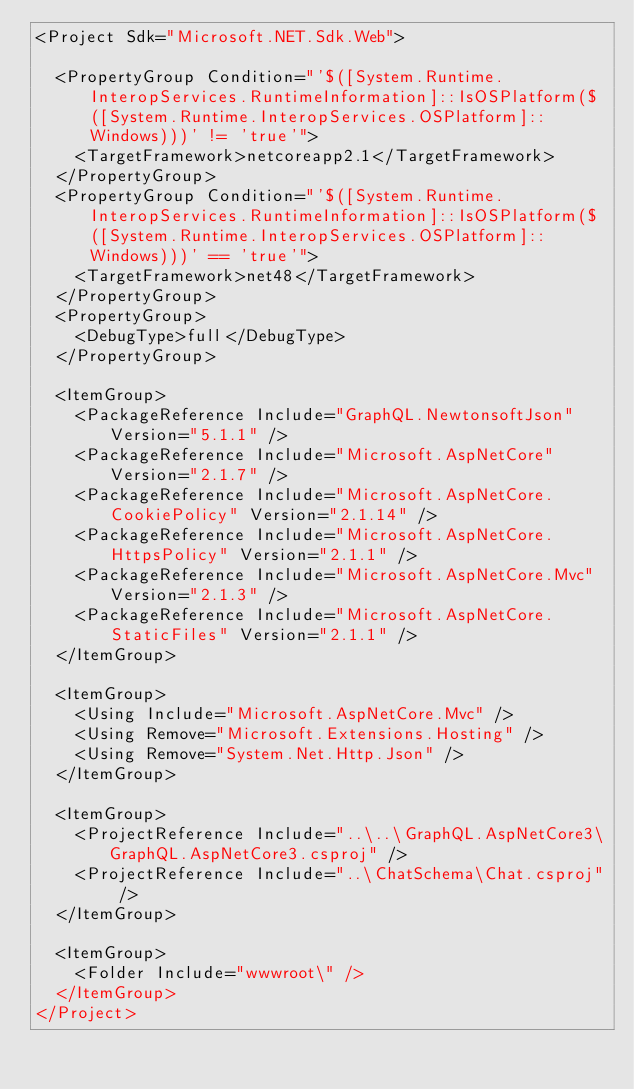<code> <loc_0><loc_0><loc_500><loc_500><_XML_><Project Sdk="Microsoft.NET.Sdk.Web">

  <PropertyGroup Condition="'$([System.Runtime.InteropServices.RuntimeInformation]::IsOSPlatform($([System.Runtime.InteropServices.OSPlatform]::Windows)))' != 'true'">
    <TargetFramework>netcoreapp2.1</TargetFramework>
  </PropertyGroup>
  <PropertyGroup Condition="'$([System.Runtime.InteropServices.RuntimeInformation]::IsOSPlatform($([System.Runtime.InteropServices.OSPlatform]::Windows)))' == 'true'">
    <TargetFramework>net48</TargetFramework>
  </PropertyGroup>
  <PropertyGroup>
    <DebugType>full</DebugType>
  </PropertyGroup>

  <ItemGroup>
    <PackageReference Include="GraphQL.NewtonsoftJson" Version="5.1.1" />
    <PackageReference Include="Microsoft.AspNetCore" Version="2.1.7" />
    <PackageReference Include="Microsoft.AspNetCore.CookiePolicy" Version="2.1.14" />
    <PackageReference Include="Microsoft.AspNetCore.HttpsPolicy" Version="2.1.1" />
    <PackageReference Include="Microsoft.AspNetCore.Mvc" Version="2.1.3" />
    <PackageReference Include="Microsoft.AspNetCore.StaticFiles" Version="2.1.1" />
  </ItemGroup>

  <ItemGroup>
    <Using Include="Microsoft.AspNetCore.Mvc" />
    <Using Remove="Microsoft.Extensions.Hosting" />
    <Using Remove="System.Net.Http.Json" />
  </ItemGroup>

  <ItemGroup>
    <ProjectReference Include="..\..\GraphQL.AspNetCore3\GraphQL.AspNetCore3.csproj" />
    <ProjectReference Include="..\ChatSchema\Chat.csproj" />
  </ItemGroup>

  <ItemGroup>
    <Folder Include="wwwroot\" />
  </ItemGroup>
</Project>
</code> 